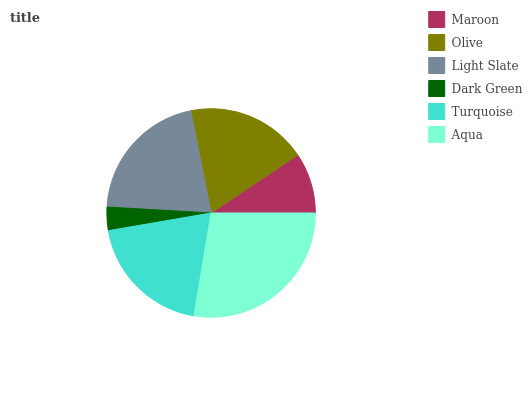Is Dark Green the minimum?
Answer yes or no. Yes. Is Aqua the maximum?
Answer yes or no. Yes. Is Olive the minimum?
Answer yes or no. No. Is Olive the maximum?
Answer yes or no. No. Is Olive greater than Maroon?
Answer yes or no. Yes. Is Maroon less than Olive?
Answer yes or no. Yes. Is Maroon greater than Olive?
Answer yes or no. No. Is Olive less than Maroon?
Answer yes or no. No. Is Turquoise the high median?
Answer yes or no. Yes. Is Olive the low median?
Answer yes or no. Yes. Is Maroon the high median?
Answer yes or no. No. Is Dark Green the low median?
Answer yes or no. No. 